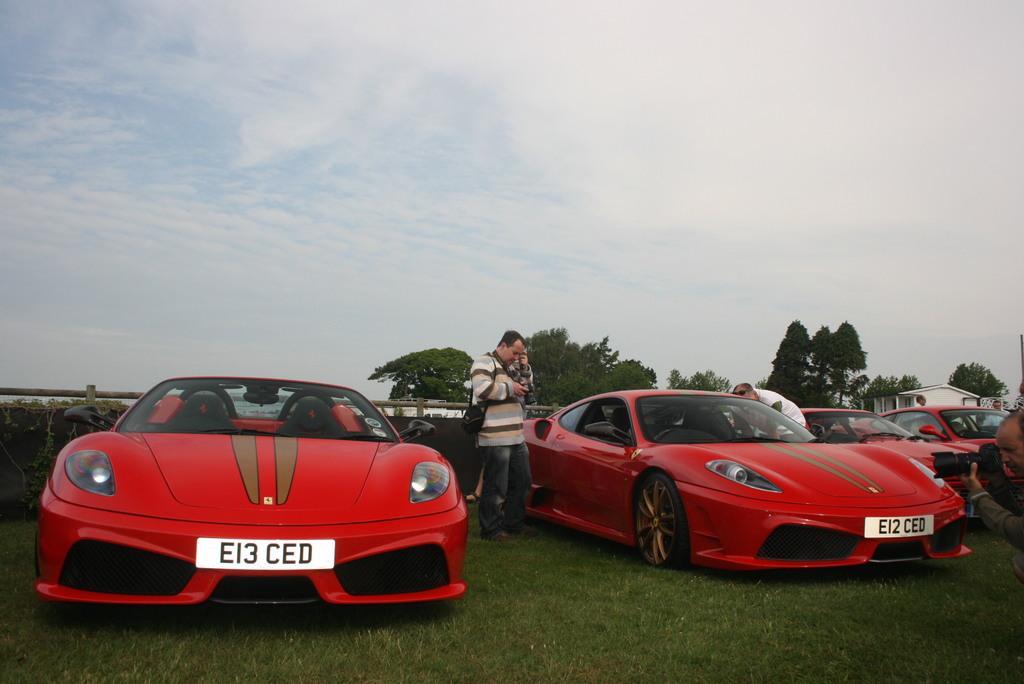In one or two sentences, can you explain what this image depicts? In the foreground of this picture, there are red color cars on the grass and few persons standing beside. In the background, there is a railing, trees, sky and the cloud. 